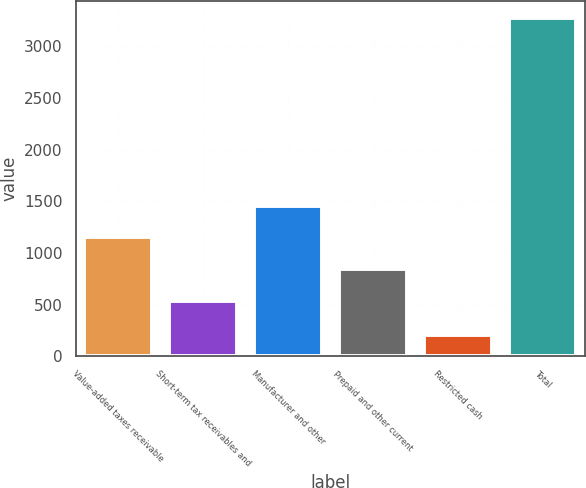<chart> <loc_0><loc_0><loc_500><loc_500><bar_chart><fcel>Value-added taxes receivable<fcel>Short-term tax receivables and<fcel>Manufacturer and other<fcel>Prepaid and other current<fcel>Restricted cash<fcel>Total<nl><fcel>1150.2<fcel>535<fcel>1457.8<fcel>842.6<fcel>204<fcel>3280<nl></chart> 